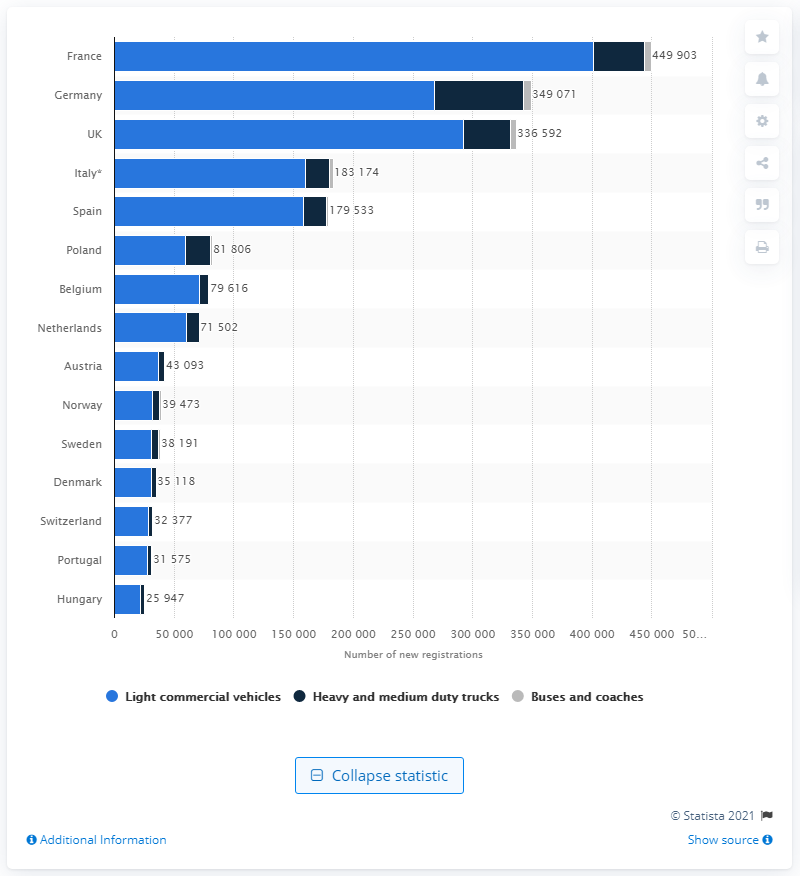Mention a couple of crucial points in this snapshot. France had the highest number of commercial vehicle sales in 2020. 